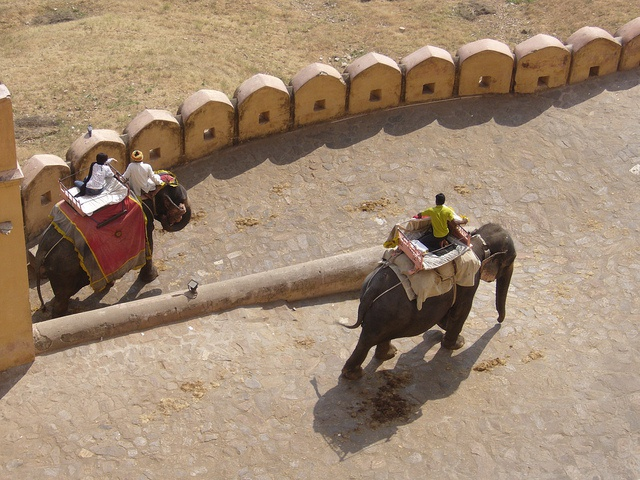Describe the objects in this image and their specific colors. I can see elephant in tan, black, and gray tones, elephant in tan, black, and maroon tones, people in tan, olive, black, maroon, and lightgray tones, people in tan, darkgray, gray, and white tones, and people in tan, darkgray, black, lightgray, and gray tones in this image. 